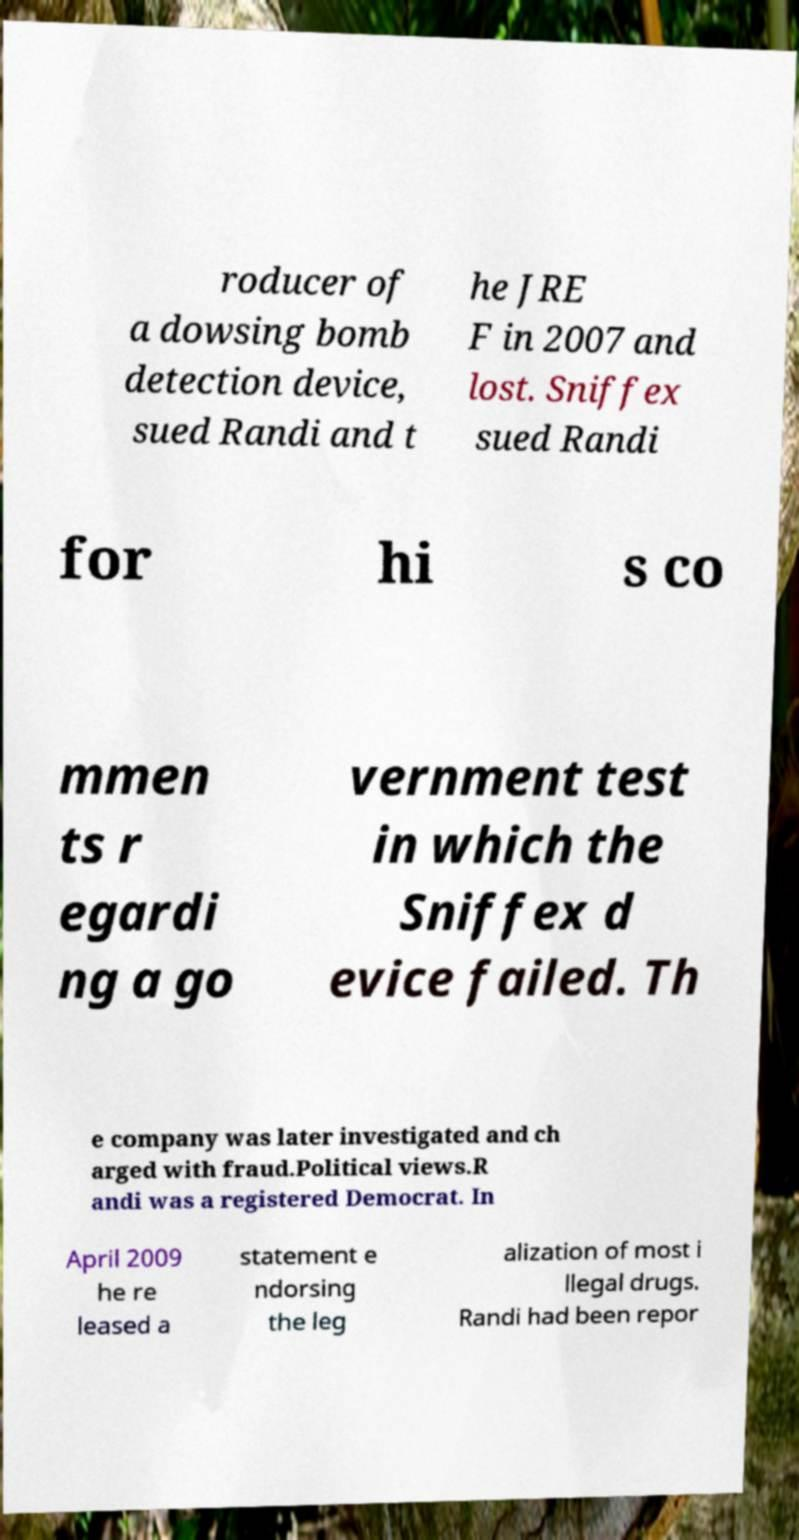What messages or text are displayed in this image? I need them in a readable, typed format. roducer of a dowsing bomb detection device, sued Randi and t he JRE F in 2007 and lost. Sniffex sued Randi for hi s co mmen ts r egardi ng a go vernment test in which the Sniffex d evice failed. Th e company was later investigated and ch arged with fraud.Political views.R andi was a registered Democrat. In April 2009 he re leased a statement e ndorsing the leg alization of most i llegal drugs. Randi had been repor 